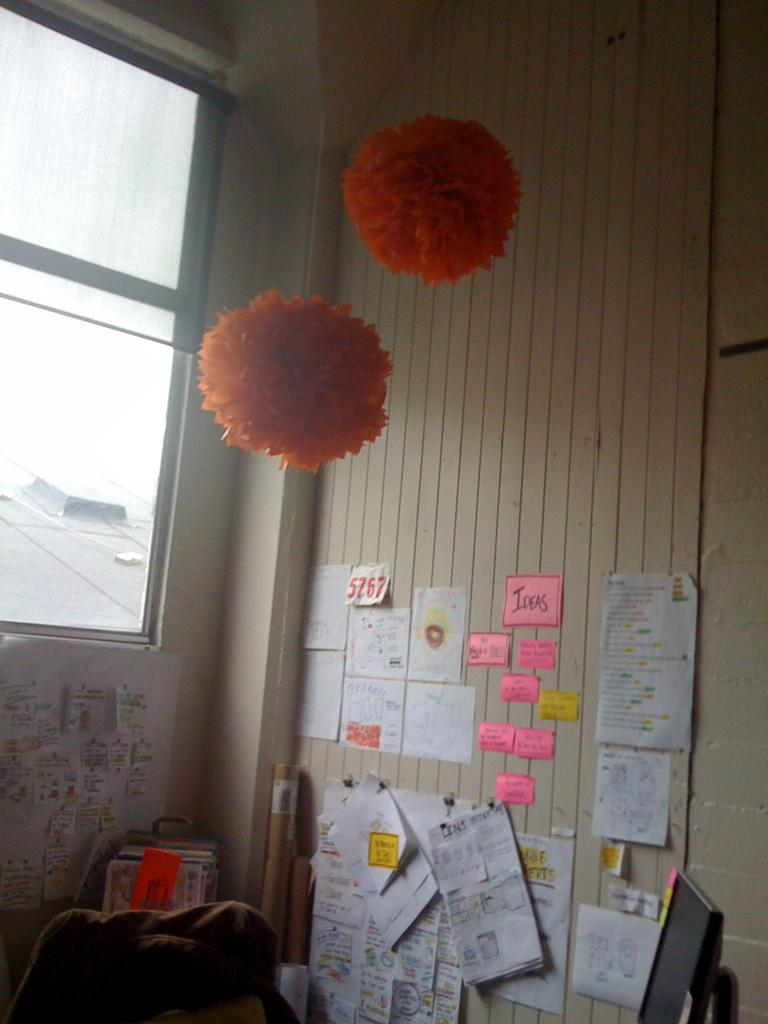What can be seen on the wall in the image? There are posts on the wall in the image. Where is the monitor located in the image? The monitor is in the bottom right corner of the image. What objects are in the middle of the image? There are paper balls in the middle of the image. What type of chin is visible on the monitor in the image? There is no chin present on the monitor in the image. What boundary can be seen separating the paper balls from the rest of the image? There is no boundary separating the paper balls from the rest of the image; they are all within the same space. 